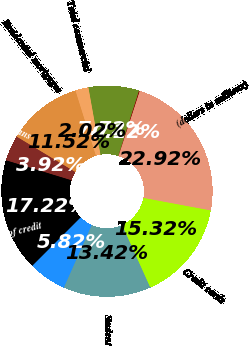<chart> <loc_0><loc_0><loc_500><loc_500><pie_chart><fcel>(dollars in millions)<fcel>Commercial<fcel>Commercial real estate<fcel>Total commercial<fcel>Residential mortgages<fcel>Home equity loans<fcel>Home equity lines of credit<fcel>Home equity loans serviced by<fcel>Student<fcel>Credit cards<nl><fcel>22.92%<fcel>0.12%<fcel>7.72%<fcel>2.02%<fcel>11.52%<fcel>3.92%<fcel>17.22%<fcel>5.82%<fcel>13.42%<fcel>15.32%<nl></chart> 